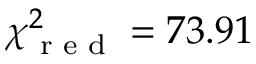<formula> <loc_0><loc_0><loc_500><loc_500>\chi _ { r e d } ^ { 2 } = 7 3 . 9 1</formula> 